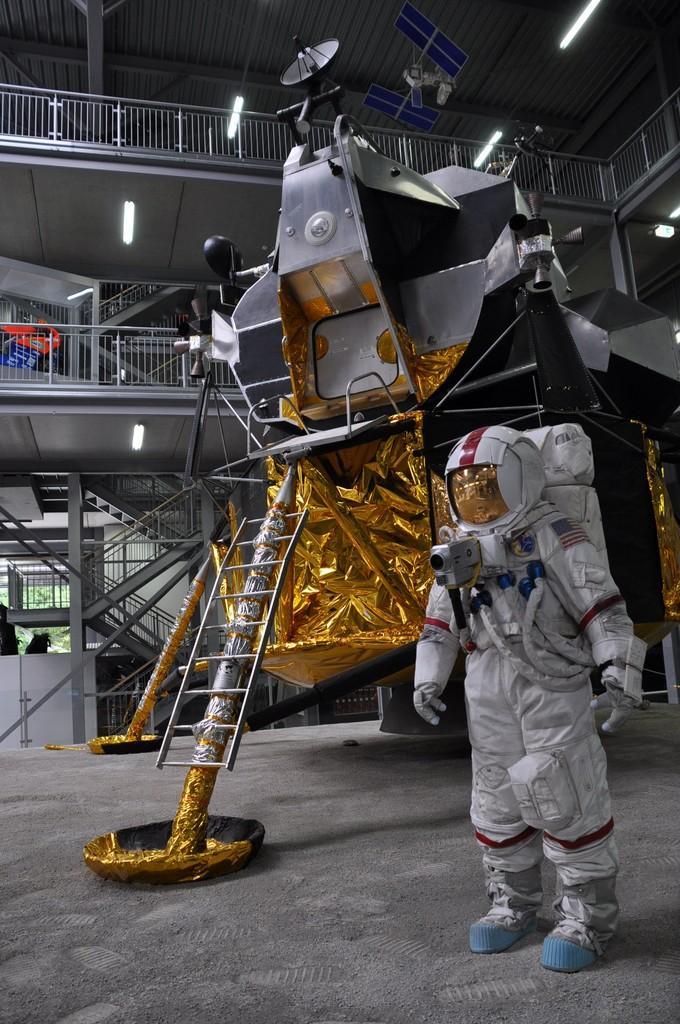Please provide a concise description of this image. In the foreground I can see a person in uniform, machines and metal rods on the floor. In the background I can see a fence, staircase, lights on a rooftop. This image is taken may be in a hall. 